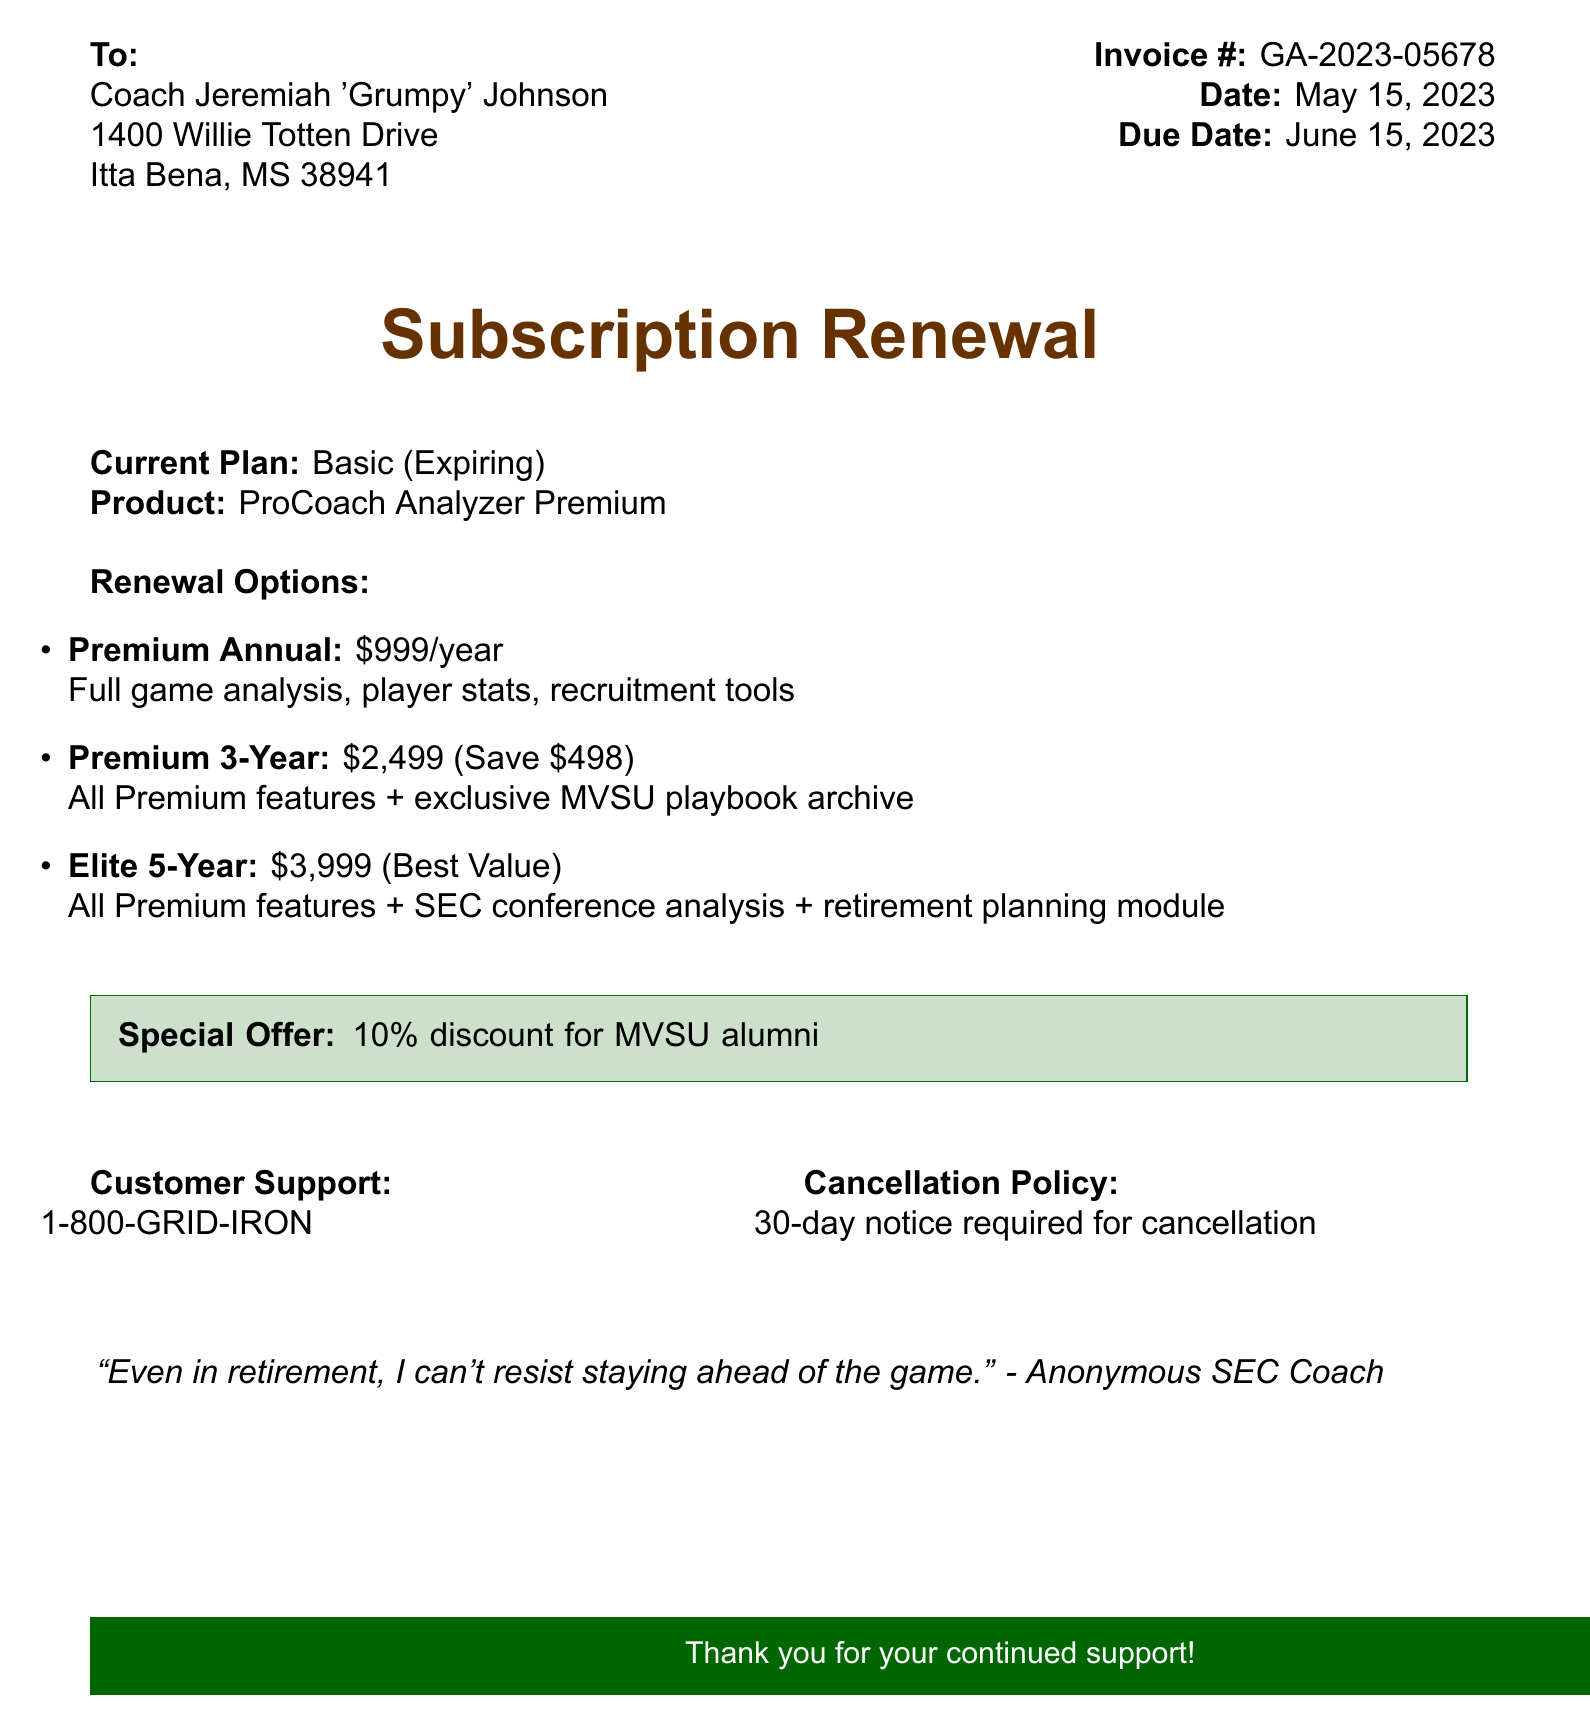What is the invoice number? The invoice number is specifically stated in the document as GA-2023-05678.
Answer: GA-2023-05678 What is the due date for the renewal? The due date is indicated in the document and is June 15, 2023.
Answer: June 15, 2023 What is the price for the Premium 3-Year option? The document mentions this pricing as \$2,499 for the Premium 3-Year renewal option.
Answer: $2,499 What discount is offered for MVSU alumni? The document states a special offer of a discount, specifically 10%.
Answer: 10% Which plan is expiring? The plan that is set to expire is labeled as "Basic (Expiring)" in the document.
Answer: Basic (Expiring) How many game analysis features are included in the Premium Annual plan? This plan includes "Full game analysis, player stats, recruitment tools," which answers the query regarding features.
Answer: Full game analysis, player stats, recruitment tools What is the customer support phone number? The phone number provided for customer support is noted as 1-800-GRID-IRON.
Answer: 1-800-GRID-IRON How long is the notice required for cancellation? The cancellation policy in the document specifies that a 30-day notice is required for cancellation.
Answer: 30-day 